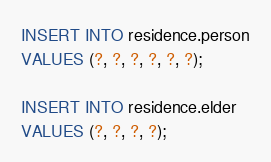<code> <loc_0><loc_0><loc_500><loc_500><_SQL_>INSERT INTO residence.person
VALUES (?, ?, ?, ?, ?, ?);

INSERT INTO residence.elder
VALUES (?, ?, ?, ?);</code> 